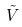Convert formula to latex. <formula><loc_0><loc_0><loc_500><loc_500>\tilde { V }</formula> 